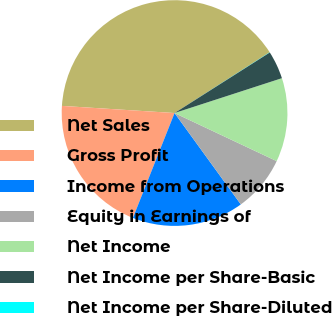Convert chart. <chart><loc_0><loc_0><loc_500><loc_500><pie_chart><fcel>Net Sales<fcel>Gross Profit<fcel>Income from Operations<fcel>Equity in Earnings of<fcel>Net Income<fcel>Net Income per Share-Basic<fcel>Net Income per Share-Diluted<nl><fcel>39.94%<fcel>19.99%<fcel>16.0%<fcel>8.01%<fcel>12.0%<fcel>4.02%<fcel>0.03%<nl></chart> 